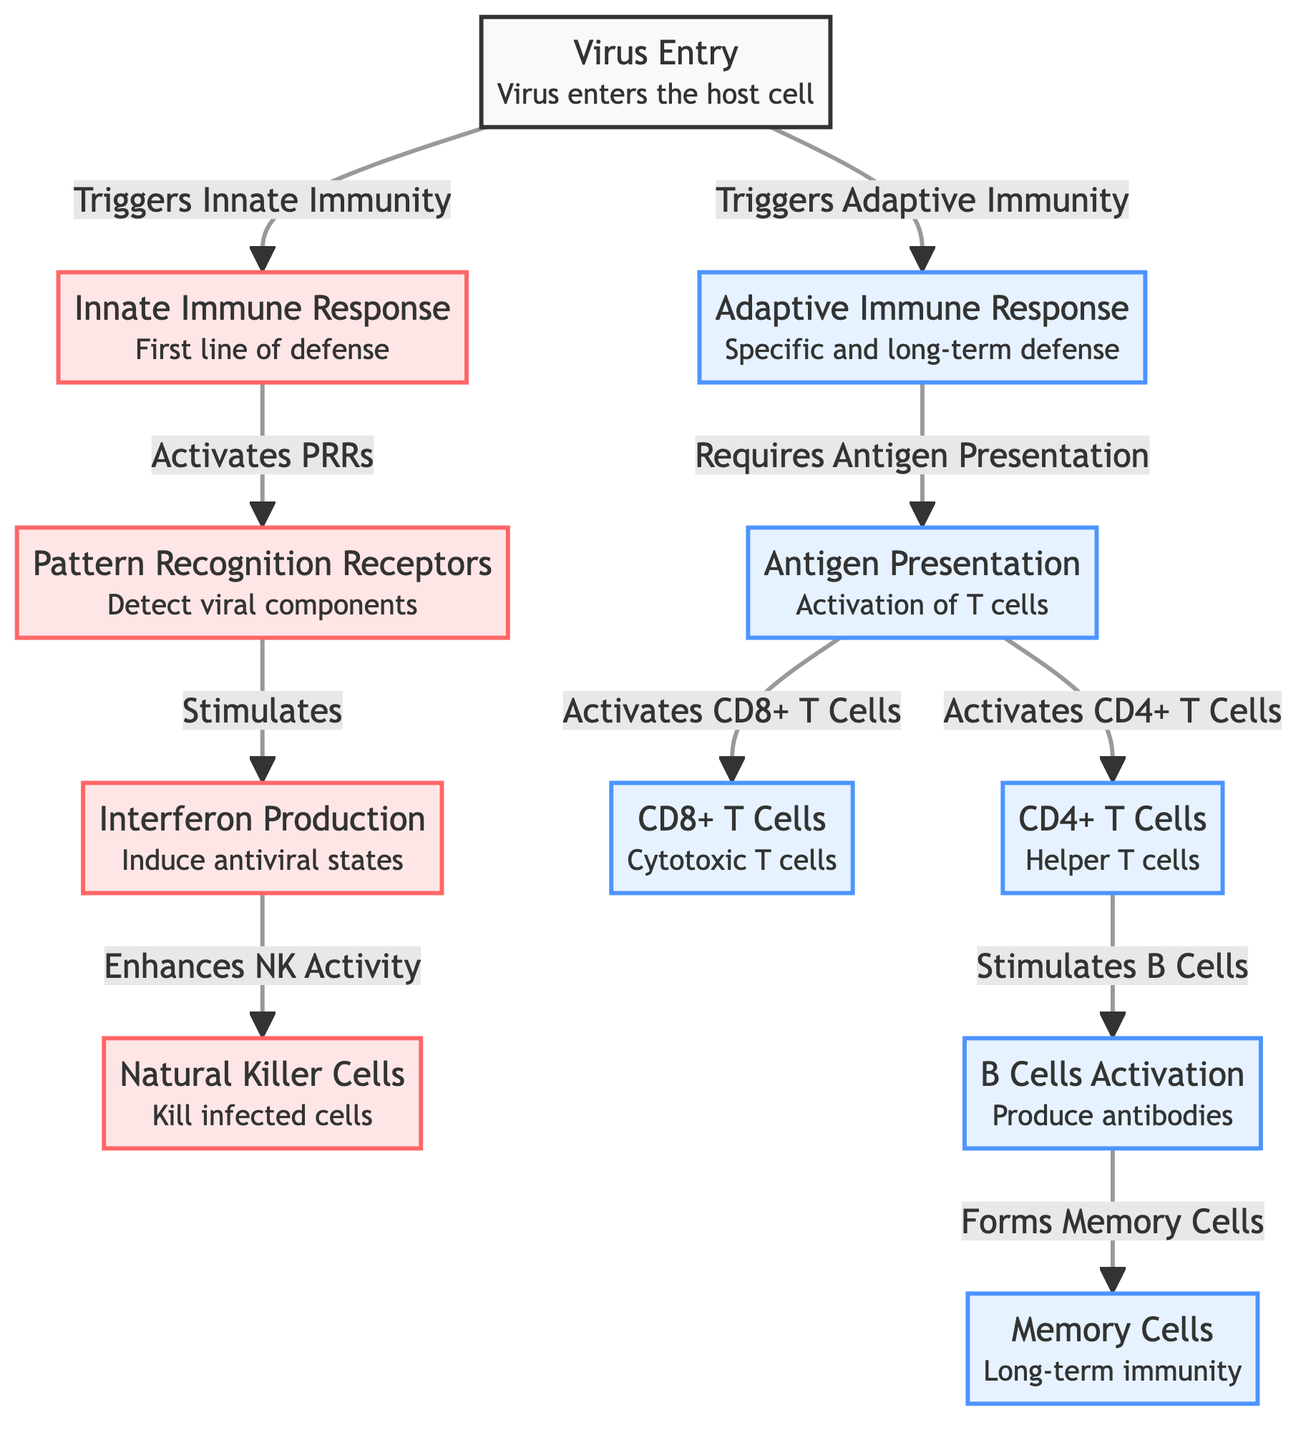What triggers innate immunity? The diagram shows that virus entry triggers the innate immune response, indicating that the presence of the virus initiates the first line of defense.
Answer: Virus Entry How many cells are part of the adaptive immune response? The diagram includes three specific cell types under the adaptive immune response: CD8+ T Cells, CD4+ T Cells, and B Cells, which are all essential components of this response.
Answer: Three Which cells are responsible for killing infected cells? The diagram indicates that natural killer cells are the specific cells that kill infected cells as part of the innate immune response.
Answer: Natural Killer Cells What activates B Cells? According to the diagram, CD4+ T Cells stimulate B Cells, leading to their activation. This indicates that the helper T cells play a crucial role in initiating B cell activity.
Answer: CD4+ T Cells What is the relationship between antigen presentation and T cell activation? The diagram illustrates that antigen presentation is essential for activating both CD8+ T Cells and CD4+ T Cells, highlighting a critical step in the adaptive immune response pathway.
Answer: Requires Antigen Presentation Which mechanism provides long-term immunity? The diagram indicates that memory cells are formed after B cells activation, which is responsible for providing long-term immunity against previously encountered pathogens.
Answer: Memory Cells What enhances natural killer activity? The flowchart specifies that interferon production enhances the activity of natural killer cells, indicating a supportive role of interferon in boosting innate responses.
Answer: Interferon Production How does the virus initially interact with the immune system? The diagram shows that the virus enters the host cell first, which initiates both innate and adaptive immune responses based on the subsequent actions depicted in the flowchart.
Answer: Virus Entry Which immune response is considered the first line of defense? The innate immune response is highlighted in the diagram as the first line of defense against viral infections, emphasizing its immediacy in the immune response process.
Answer: Innate Immune Response 